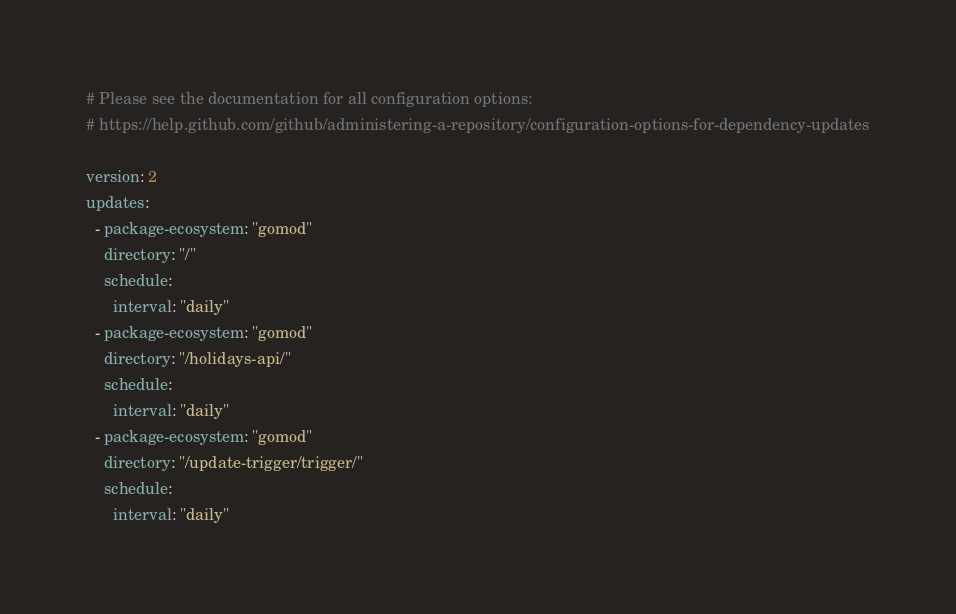<code> <loc_0><loc_0><loc_500><loc_500><_YAML_># Please see the documentation for all configuration options:
# https://help.github.com/github/administering-a-repository/configuration-options-for-dependency-updates

version: 2
updates:
  - package-ecosystem: "gomod"
    directory: "/"
    schedule:
      interval: "daily"
  - package-ecosystem: "gomod"
    directory: "/holidays-api/"
    schedule:
      interval: "daily"
  - package-ecosystem: "gomod"
    directory: "/update-trigger/trigger/"
    schedule:
      interval: "daily"
</code> 